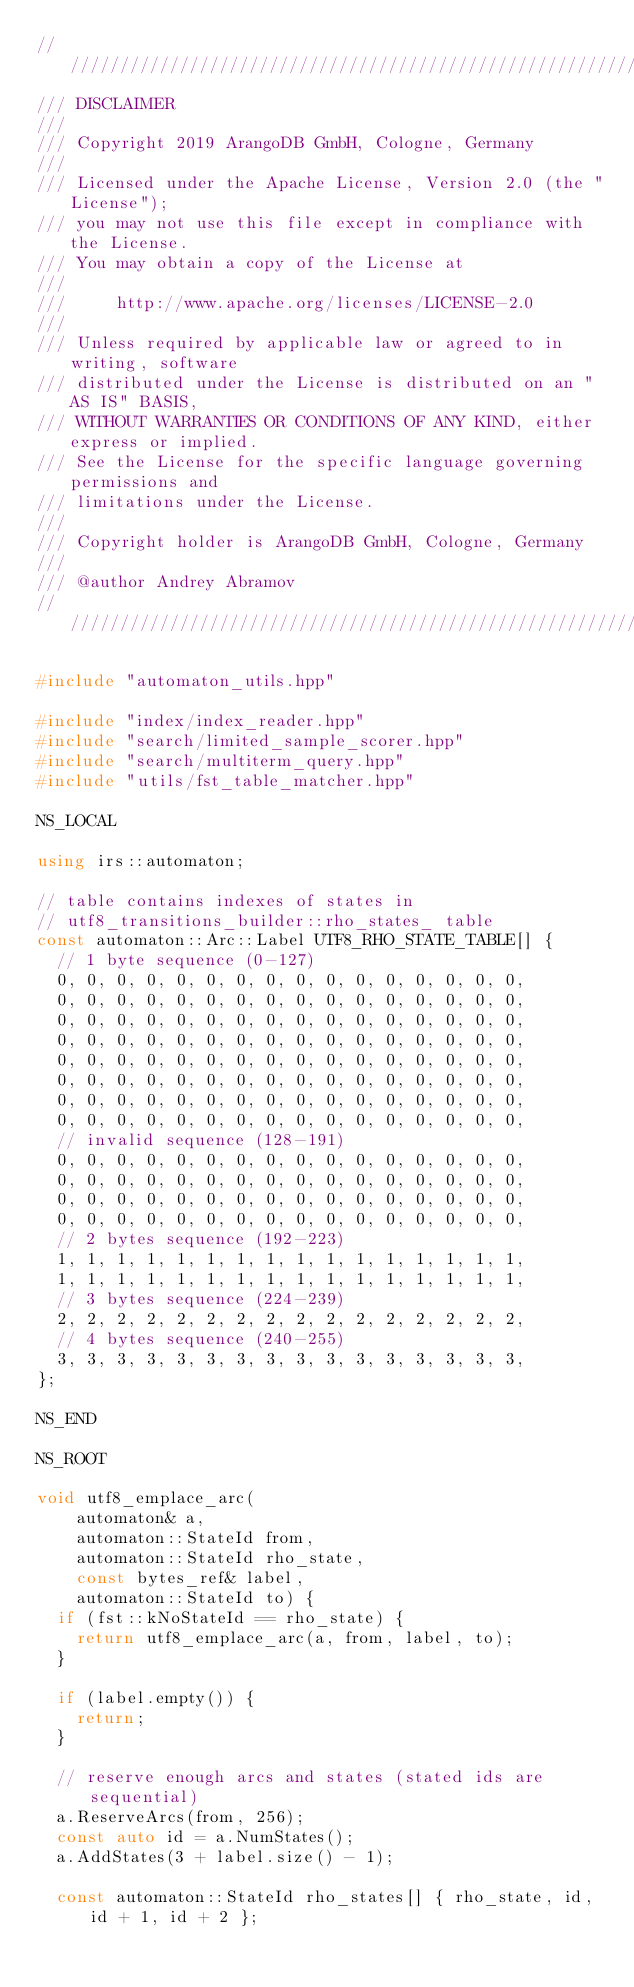<code> <loc_0><loc_0><loc_500><loc_500><_C++_>////////////////////////////////////////////////////////////////////////////////
/// DISCLAIMER
///
/// Copyright 2019 ArangoDB GmbH, Cologne, Germany
///
/// Licensed under the Apache License, Version 2.0 (the "License");
/// you may not use this file except in compliance with the License.
/// You may obtain a copy of the License at
///
///     http://www.apache.org/licenses/LICENSE-2.0
///
/// Unless required by applicable law or agreed to in writing, software
/// distributed under the License is distributed on an "AS IS" BASIS,
/// WITHOUT WARRANTIES OR CONDITIONS OF ANY KIND, either express or implied.
/// See the License for the specific language governing permissions and
/// limitations under the License.
///
/// Copyright holder is ArangoDB GmbH, Cologne, Germany
///
/// @author Andrey Abramov
////////////////////////////////////////////////////////////////////////////////

#include "automaton_utils.hpp"

#include "index/index_reader.hpp"
#include "search/limited_sample_scorer.hpp"
#include "search/multiterm_query.hpp"
#include "utils/fst_table_matcher.hpp"

NS_LOCAL

using irs::automaton;

// table contains indexes of states in
// utf8_transitions_builder::rho_states_ table
const automaton::Arc::Label UTF8_RHO_STATE_TABLE[] {
  // 1 byte sequence (0-127)
  0, 0, 0, 0, 0, 0, 0, 0, 0, 0, 0, 0, 0, 0, 0, 0,
  0, 0, 0, 0, 0, 0, 0, 0, 0, 0, 0, 0, 0, 0, 0, 0,
  0, 0, 0, 0, 0, 0, 0, 0, 0, 0, 0, 0, 0, 0, 0, 0,
  0, 0, 0, 0, 0, 0, 0, 0, 0, 0, 0, 0, 0, 0, 0, 0,
  0, 0, 0, 0, 0, 0, 0, 0, 0, 0, 0, 0, 0, 0, 0, 0,
  0, 0, 0, 0, 0, 0, 0, 0, 0, 0, 0, 0, 0, 0, 0, 0,
  0, 0, 0, 0, 0, 0, 0, 0, 0, 0, 0, 0, 0, 0, 0, 0,
  0, 0, 0, 0, 0, 0, 0, 0, 0, 0, 0, 0, 0, 0, 0, 0,
  // invalid sequence (128-191)
  0, 0, 0, 0, 0, 0, 0, 0, 0, 0, 0, 0, 0, 0, 0, 0,
  0, 0, 0, 0, 0, 0, 0, 0, 0, 0, 0, 0, 0, 0, 0, 0,
  0, 0, 0, 0, 0, 0, 0, 0, 0, 0, 0, 0, 0, 0, 0, 0,
  0, 0, 0, 0, 0, 0, 0, 0, 0, 0, 0, 0, 0, 0, 0, 0,
  // 2 bytes sequence (192-223)
  1, 1, 1, 1, 1, 1, 1, 1, 1, 1, 1, 1, 1, 1, 1, 1,
  1, 1, 1, 1, 1, 1, 1, 1, 1, 1, 1, 1, 1, 1, 1, 1,
  // 3 bytes sequence (224-239)
  2, 2, 2, 2, 2, 2, 2, 2, 2, 2, 2, 2, 2, 2, 2, 2,
  // 4 bytes sequence (240-255)
  3, 3, 3, 3, 3, 3, 3, 3, 3, 3, 3, 3, 3, 3, 3, 3,
};

NS_END

NS_ROOT

void utf8_emplace_arc(
    automaton& a,
    automaton::StateId from,
    automaton::StateId rho_state,
    const bytes_ref& label,
    automaton::StateId to) {
  if (fst::kNoStateId == rho_state) {
    return utf8_emplace_arc(a, from, label, to);
  }

  if (label.empty()) {
    return;
  }

  // reserve enough arcs and states (stated ids are sequential)
  a.ReserveArcs(from, 256);
  const auto id = a.NumStates();
  a.AddStates(3 + label.size() - 1);

  const automaton::StateId rho_states[] { rho_state, id, id + 1, id + 2 };
</code> 